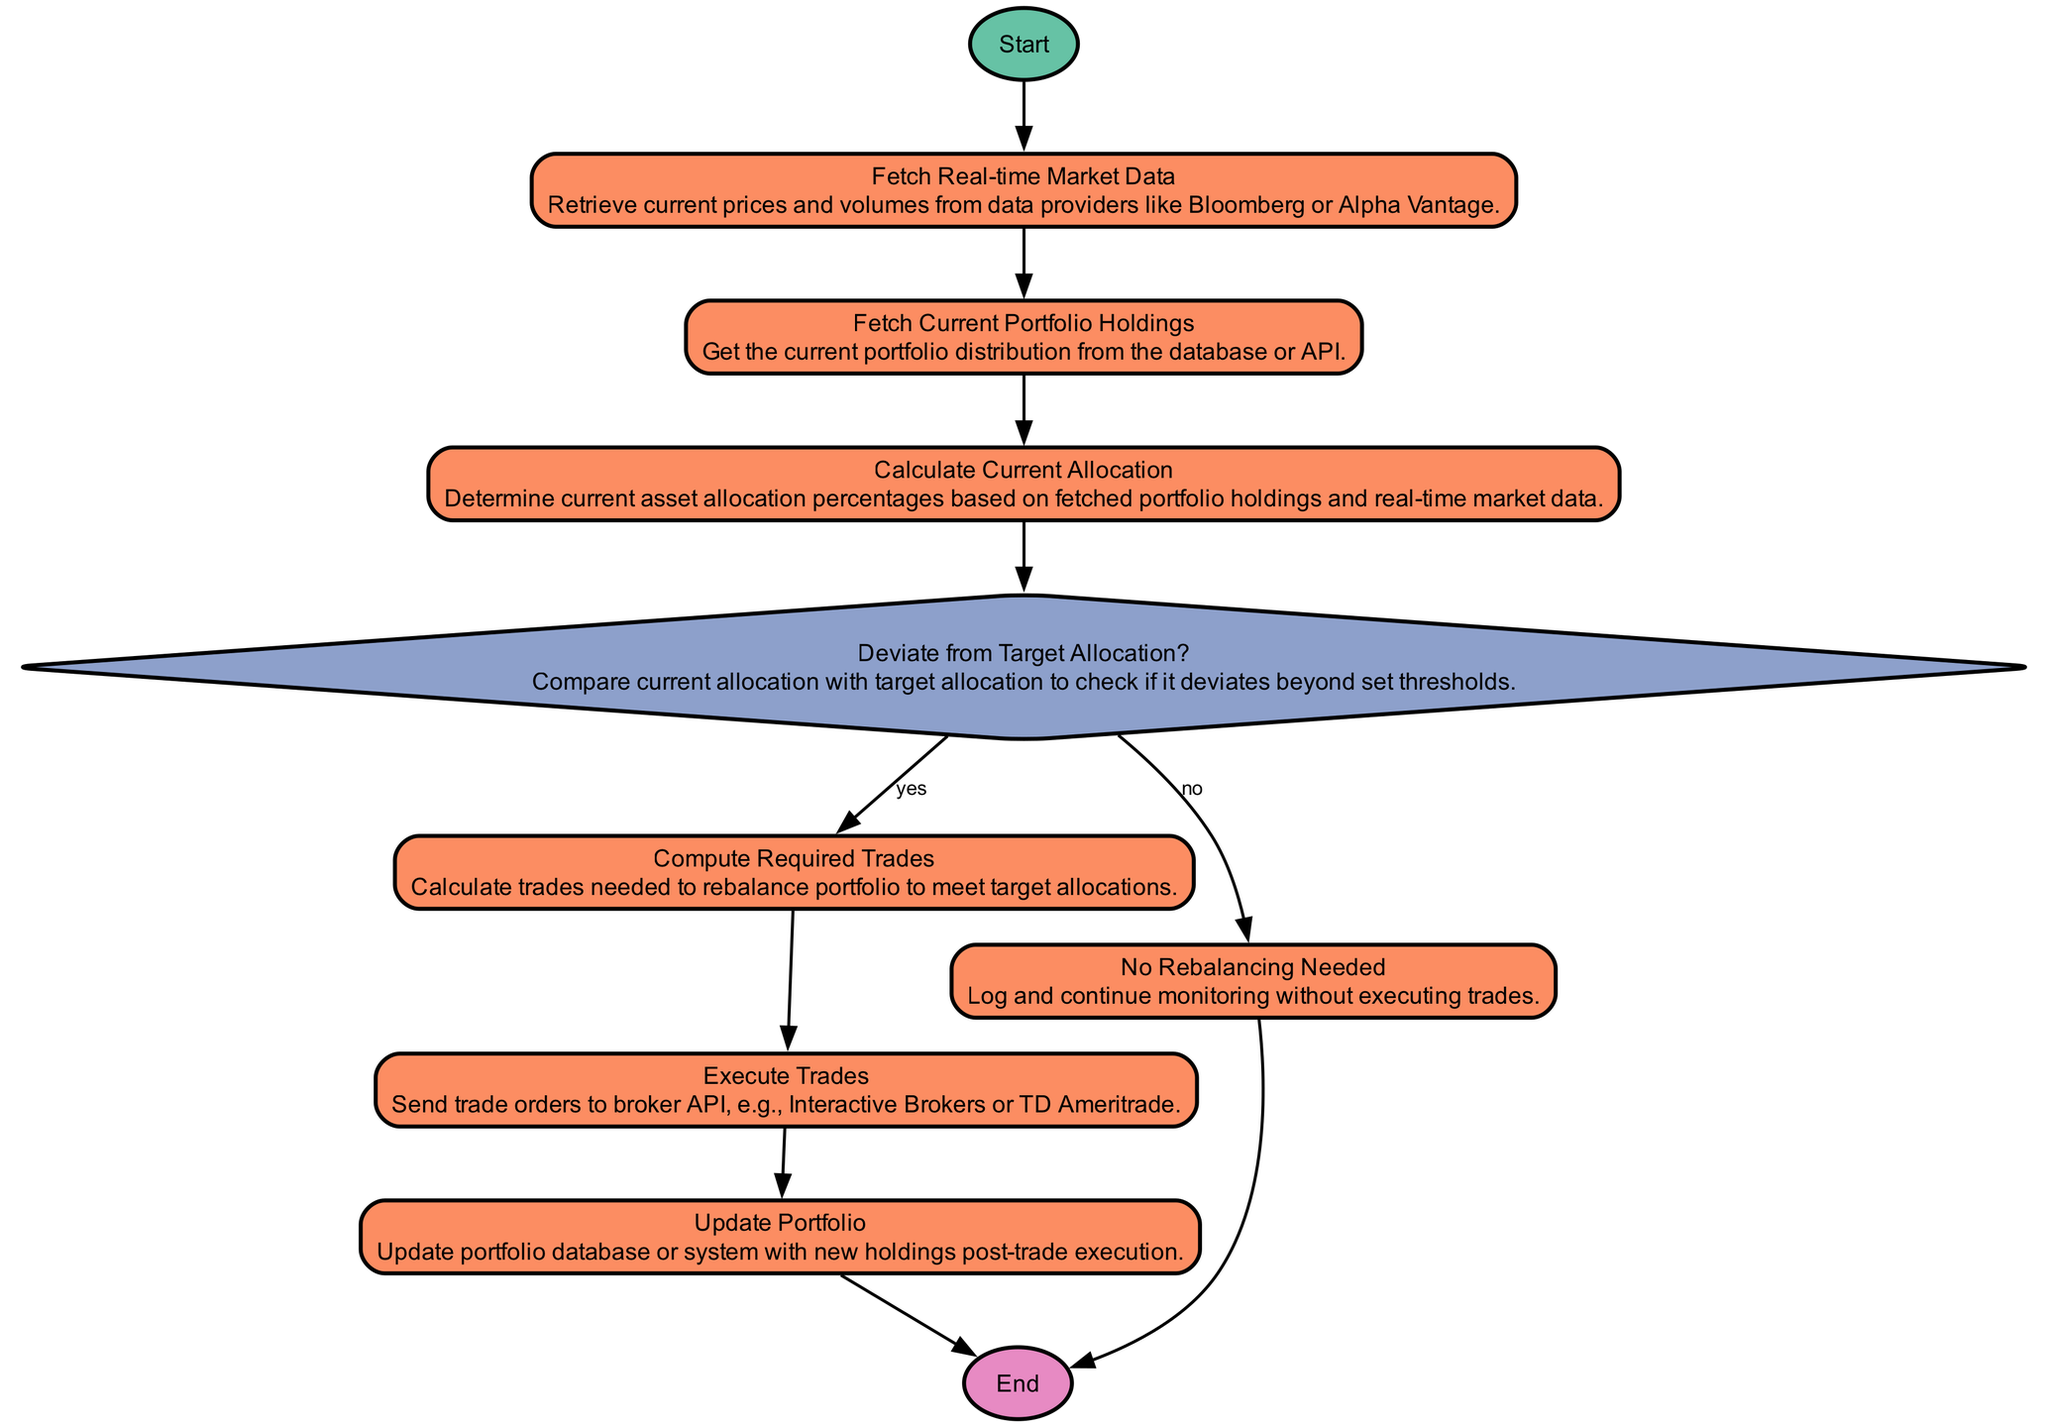What is the starting point of the algorithm? The starting point in the flow chart is labeled "Start". It's the first node where the process begins before moving to the next steps.
Answer: Start How many process nodes are present in the diagram? By counting the nodes of type "process", we can see that there are six such nodes: Fetch Real-time Market Data, Fetch Current Portfolio Holdings, Calculate Current Allocation, Compute Required Trades, Execute Trades, and Update Portfolio.
Answer: 6 What determines whether to rebalance the portfolio? The decision to rebalance the portfolio is determined by comparing the current allocation with the target allocation, which is indicated by the decision node labeled "Deviate from Target Allocation?".
Answer: Deviate from Target Allocation? What happens if no rebalancing is needed? If no rebalancing is needed, the process flows to the node labeled "No Rebalancing Needed", where it logs the event and continues monitoring without executing any trades.
Answer: No Rebalancing Needed What process follows the execution of trades? After executing trades, the next process that follows is updating the portfolio, as indicated by the flow from the "Execute Trades" node to the "Update Portfolio" node.
Answer: Update Portfolio What is the end point of this diagram? The end point of the algorithm is labeled "End", marking the conclusion of the rebalancing process after updating the portfolio.
Answer: End Which node fetches the current portfolio holdings? The node that fetches the current portfolio holdings is labeled "Fetch Current Portfolio Holdings". This node retrieves distribution data necessary for further calculations.
Answer: Fetch Current Portfolio Holdings What condition leads to the computation of required trades? The condition that leads to the computation of required trades is the positive answer (yes) to the question posed in the decision node "Deviate from Target Allocation?". If there’s a deviation, the flow continues to compute trades.
Answer: yes How many decision nodes are present in the diagram? There is one decision node in the diagram, which is the "Deviate from Target Allocation?". This node determines the next steps based on its evaluation of the current vs. target allocations.
Answer: 1 